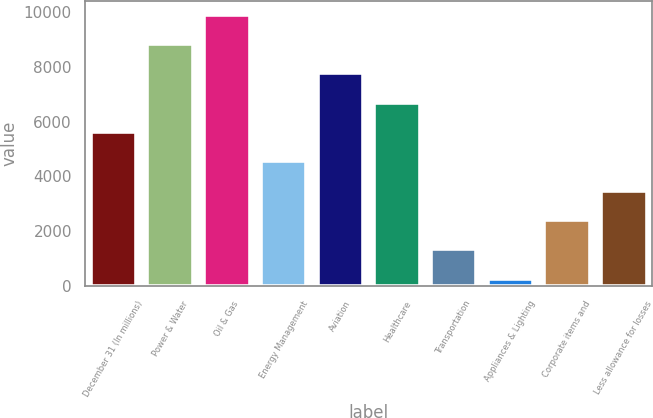Convert chart. <chart><loc_0><loc_0><loc_500><loc_500><bar_chart><fcel>December 31 (In millions)<fcel>Power & Water<fcel>Oil & Gas<fcel>Energy Management<fcel>Aviation<fcel>Healthcare<fcel>Transportation<fcel>Appliances & Lighting<fcel>Corporate items and<fcel>Less allowance for losses<nl><fcel>5621.5<fcel>8830.6<fcel>9900.3<fcel>4551.8<fcel>7760.9<fcel>6691.2<fcel>1342.7<fcel>273<fcel>2412.4<fcel>3482.1<nl></chart> 